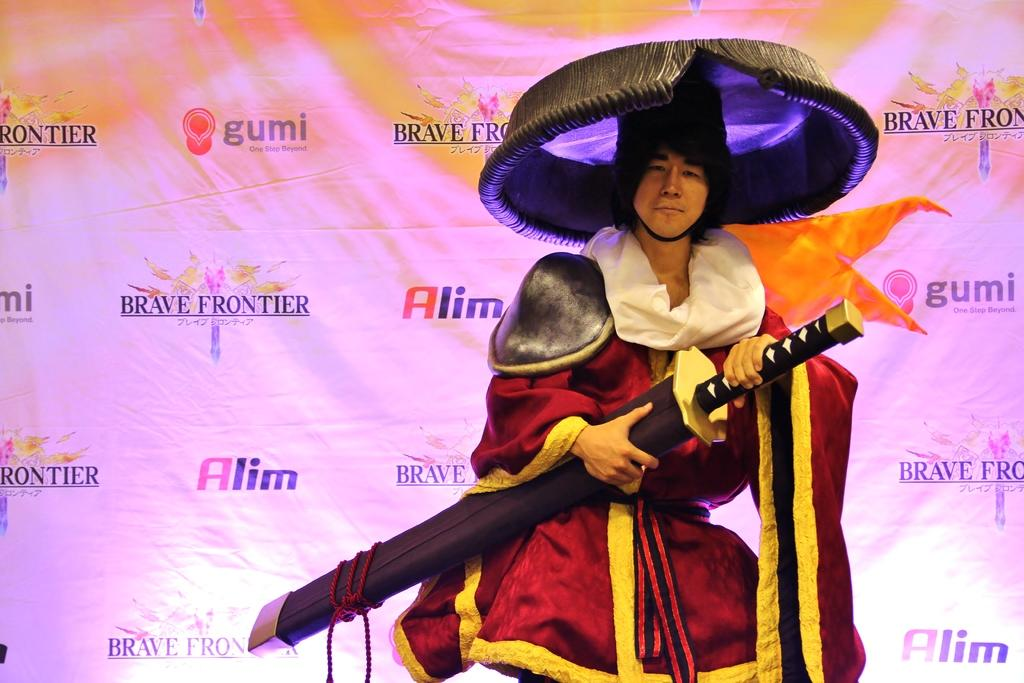What is the person in the image doing? The person is standing in the image. What is the person wearing in the image? The person is wearing a costume and a hat. What object is the person holding in the image? The person is holding a sword in his hand. What can be seen in the background of the image? There is a banner visible in the background of the image. How does the person increase the grip on the sword in the image? There is no indication in the image that the person is adjusting their grip on the sword. 